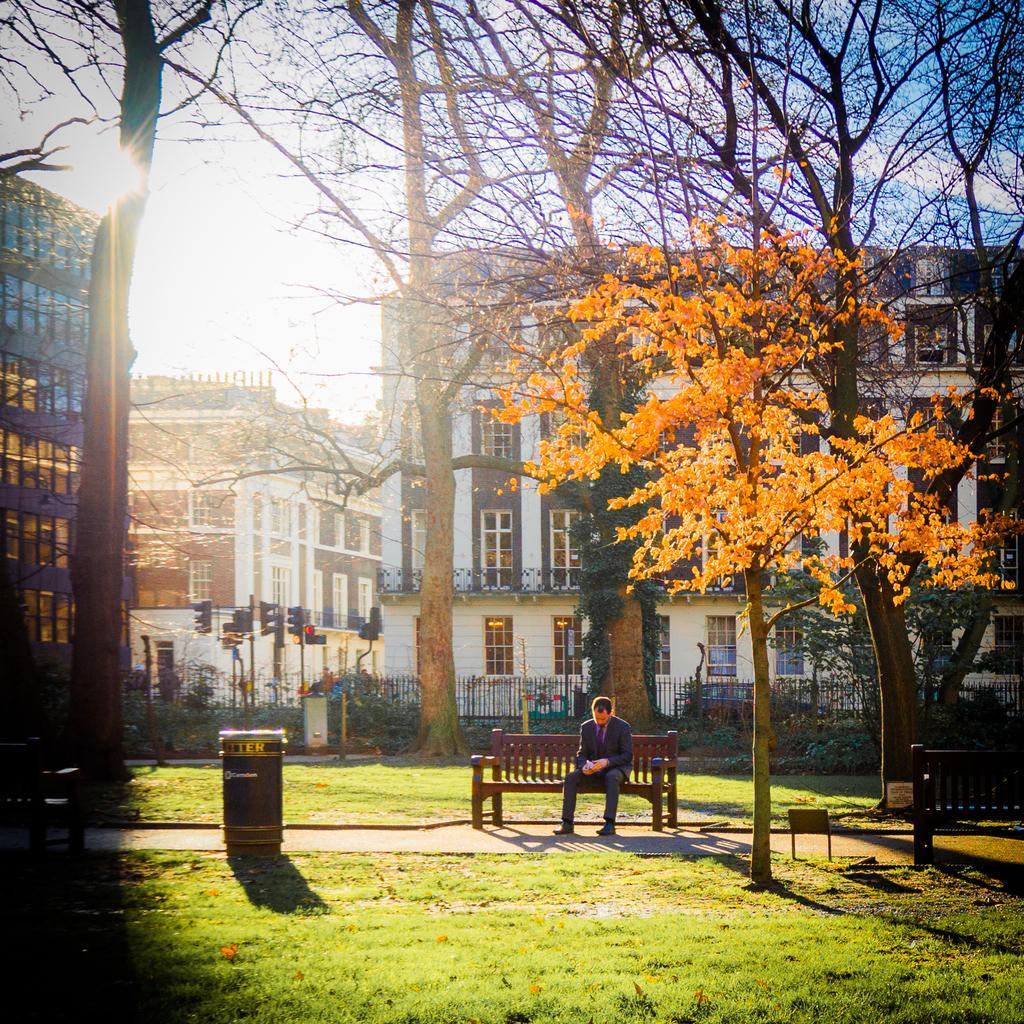How would you summarize this image in a sentence or two? In this image there are wooden benches on the ground. There is a man sitting on the bench. Behind him there are trees. In the background there are buildings and traffic signal poles. There is a railing in front of the building. To the left there is a dustbin on the ground. There is grass on the ground. At the top there is the sky. 